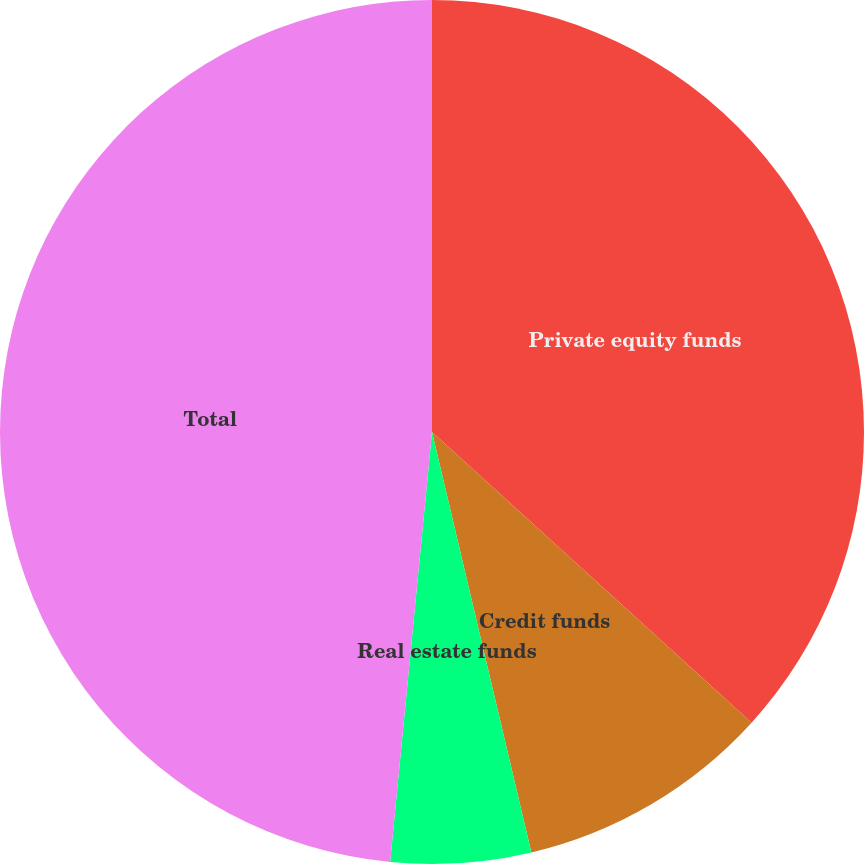<chart> <loc_0><loc_0><loc_500><loc_500><pie_chart><fcel>Private equity funds<fcel>Credit funds<fcel>Real estate funds<fcel>Total<nl><fcel>36.75%<fcel>9.56%<fcel>5.24%<fcel>48.46%<nl></chart> 